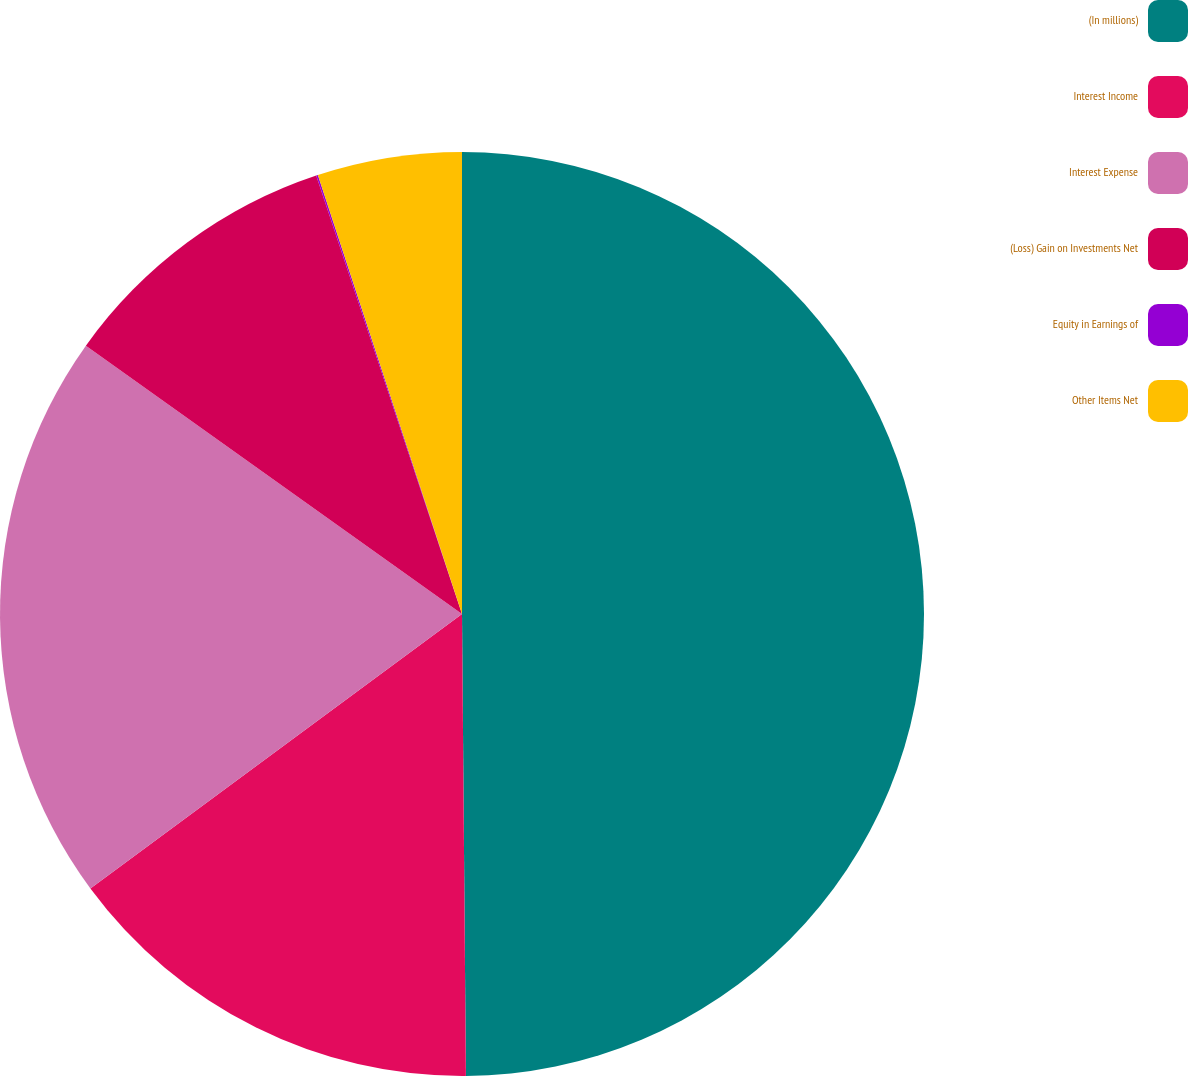Convert chart. <chart><loc_0><loc_0><loc_500><loc_500><pie_chart><fcel>(In millions)<fcel>Interest Income<fcel>Interest Expense<fcel>(Loss) Gain on Investments Net<fcel>Equity in Earnings of<fcel>Other Items Net<nl><fcel>49.87%<fcel>15.01%<fcel>19.99%<fcel>10.03%<fcel>0.06%<fcel>5.05%<nl></chart> 